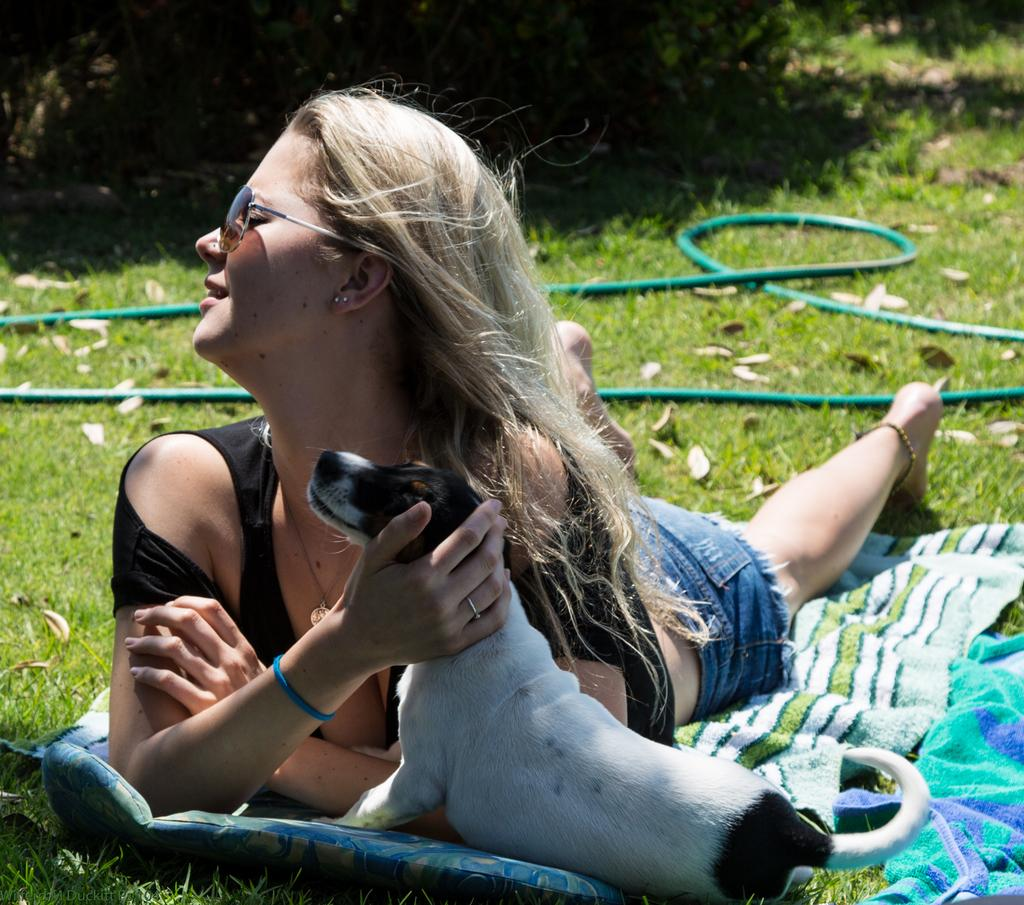What is the main subject of the image? There is a person in the image. What is the person doing in the image? The person is laying down. Is there any interaction between the person and another living being in the image? Yes, the person is holding a dog. What type of coat is the writer wearing in the image? There is no writer or coat present in the image; it features a person holding a dog while laying down. 